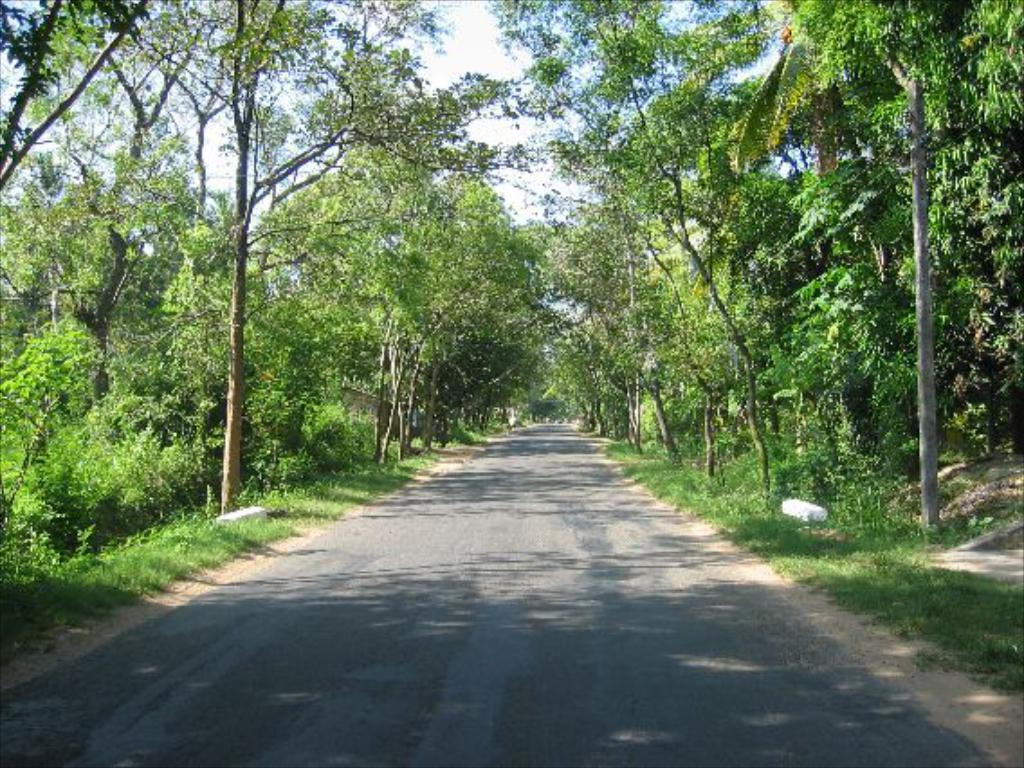What is the main feature in the middle of the image? There is a road in the middle of the image. What can be seen on both sides of the road? There are trees on either side of the road. What is visible at the top of the image? The sky is visible at the top of the image. What rule is being enforced by the nation in the image? There is no reference to a nation or any rules in the image, so it's not possible to determine what rule might be enforced. 